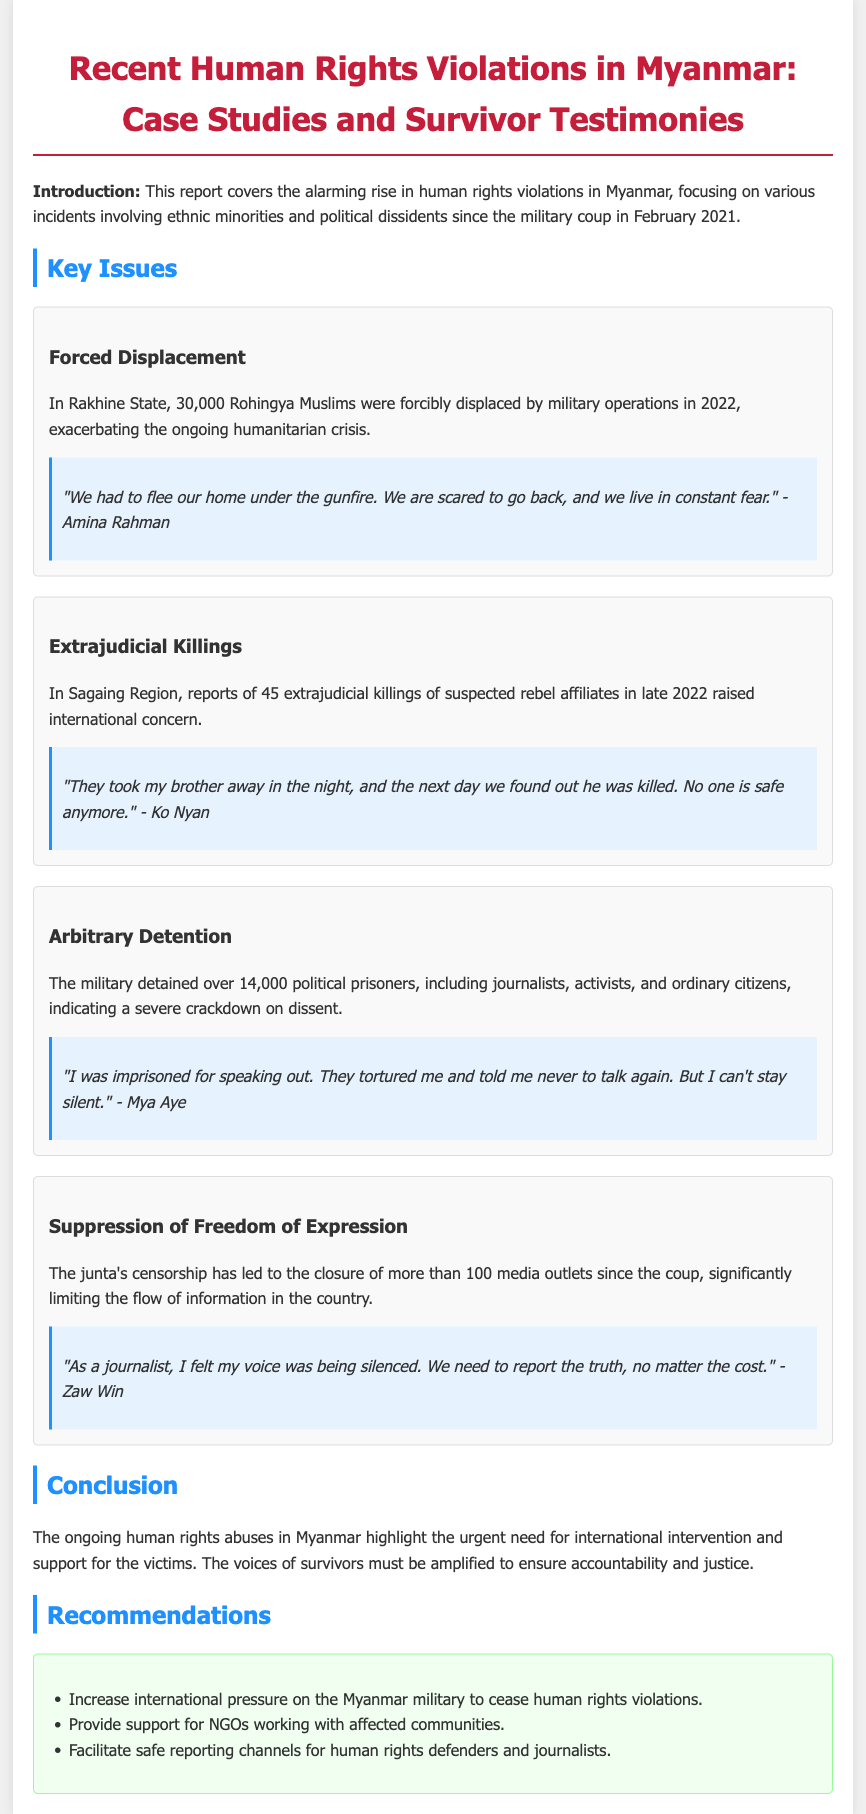What are the ethnic minorities mentioned in the report? The report specifically mentions the Rohingya Muslims as an ethnic minority affected by violations.
Answer: Rohingya Muslims How many Rohingya Muslims were forcibly displaced? The document states that 30,000 Rohingya Muslims were forcibly displaced by military operations in 2022.
Answer: 30,000 What type of violations are reported in the Sagaing Region? The report highlights reports of extrajudicial killings in the Sagaing Region related to suspected rebel affiliates.
Answer: Extrajudicial killings Who provided testimony about forced displacement? Amina Rahman is the individual who spoke about her experience regarding forced displacement in Rakhine State.
Answer: Amina Rahman What was a consequence of the military's censorship actions? The censorship led to the closure of more than 100 media outlets since the coup, limiting information flow.
Answer: Closure of more than 100 media outlets What was the number of political prisoners mentioned? The document states that over 14,000 political prisoners were detained by the military.
Answer: Over 14,000 What does Mya Aye claim about their imprisonment experience? Mya Aye's testimony mentions experiencing torture during imprisonment for speaking out.
Answer: Tortured What kind of recommendations does the report provide? The recommendations focus on increasing international pressure, supporting NGOs, and facilitating safe reporting channels.
Answer: Increase international pressure, support NGOs, facilitate safe reporting channels 